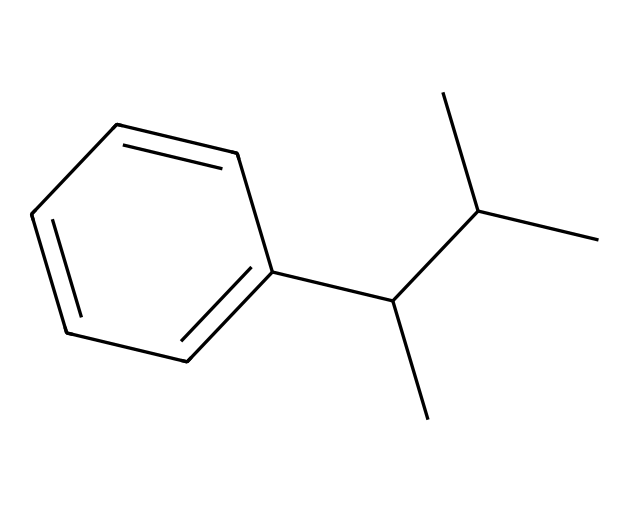What is the name of this chemical? The chemical structure indicates it is polystyrene, as it consists of a styrene monomer repeating unit and is commonly used in plastics.
Answer: polystyrene How many carbon atoms are present in this structure? By analyzing the structure, we can count a total of 15 carbon atoms, including those in the benzene ring and the linear chain.
Answer: 15 What type of bonds are primarily present in this chemical? The structure shows primarily single bonds (C-C) and double bonds (C=C in the benzene ring), indicating it has both types of bonds.
Answer: single and double What is the primary use of polystyrene in maritime contexts? Polystyrene is primarily used for disposable food containers, which are common in ship catering services due to its lightweight and insulating properties.
Answer: disposable food containers Is this chemical considered biodegradable? Polystyrene is not biodegradable and can persist in the environment for a long time, which is a major concern in waste management.
Answer: no What property of polystyrene contributes to its insulation capabilities? The inherent low thermal conductivity of polystyrene contributes to its insulation capabilities, making it useful for containing food and beverages.
Answer: low thermal conductivity How does the structure of polystyrene affect its rigidity? The linear chain structure and the presence of benzene rings contribute to the rigidity of polystyrene, providing mechanical strength.
Answer: rigidity due to structure 